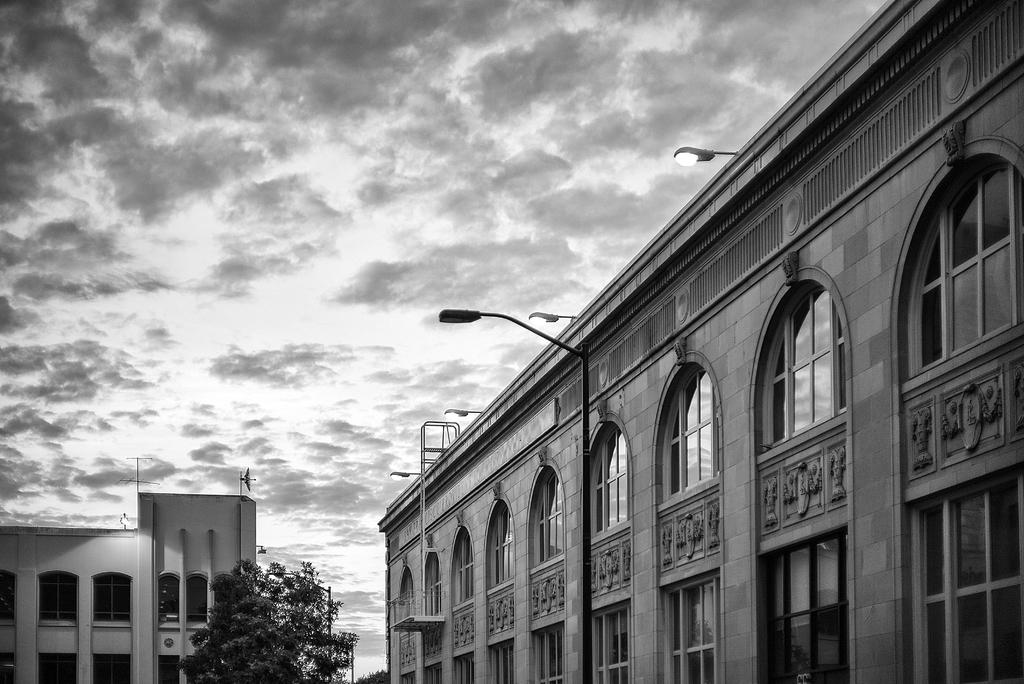What structures are located in the foreground of the image? There are buildings in the foreground of the image. What else can be seen in the foreground of the image besides buildings? There are street lights and trees in the foreground of the image. What is visible at the top of the image? The sky is visible at the top of the image. How would you describe the sky in the image? The sky is cloudy in the image. How many apples are hanging from the trees in the image? There are no apples present in the image; it only features trees without any visible fruit. What type of behavior can be observed in the street lights in the image? Street lights do not exhibit behavior, as they are inanimate objects. 